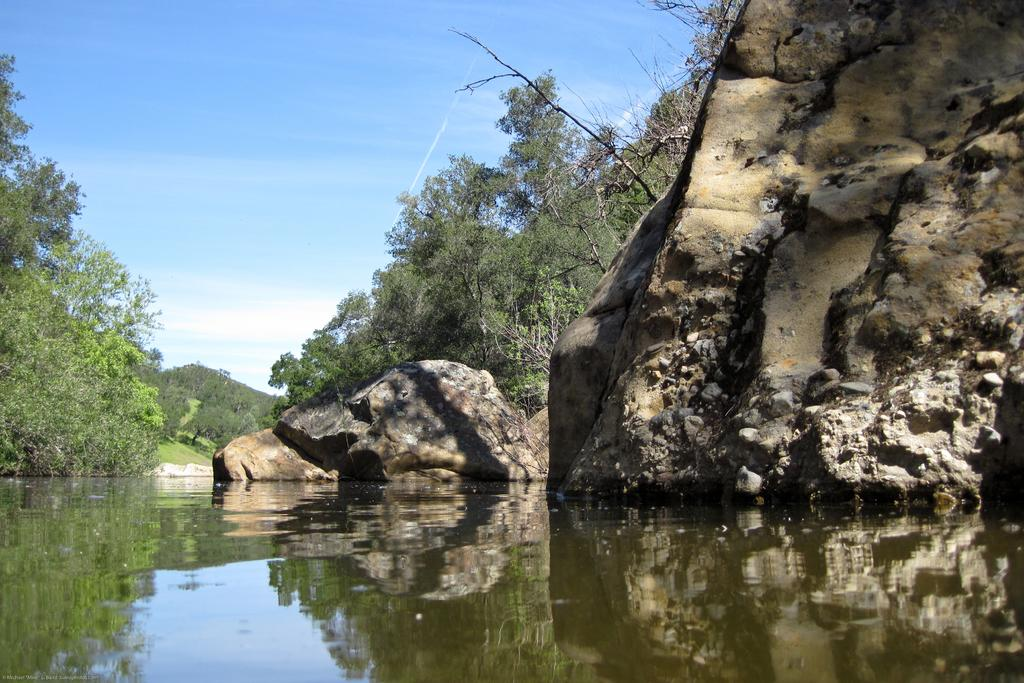What is present at the bottom of the image? There is water at the bottom of the image. What can be seen in the image besides the water? There is a rock and a hill in the image. What type of vegetation is visible in the background of the image? There are trees in the background of the image. What is visible at the top of the image? The sky is visible at the top of the image. What type of account can be seen in the wilderness in the image? There is no account present in the image, and the image does not depict a wilderness setting. What type of vessel is floating on the water in the image? There is no vessel present in the image; it only shows water, a rock, and a hill. 